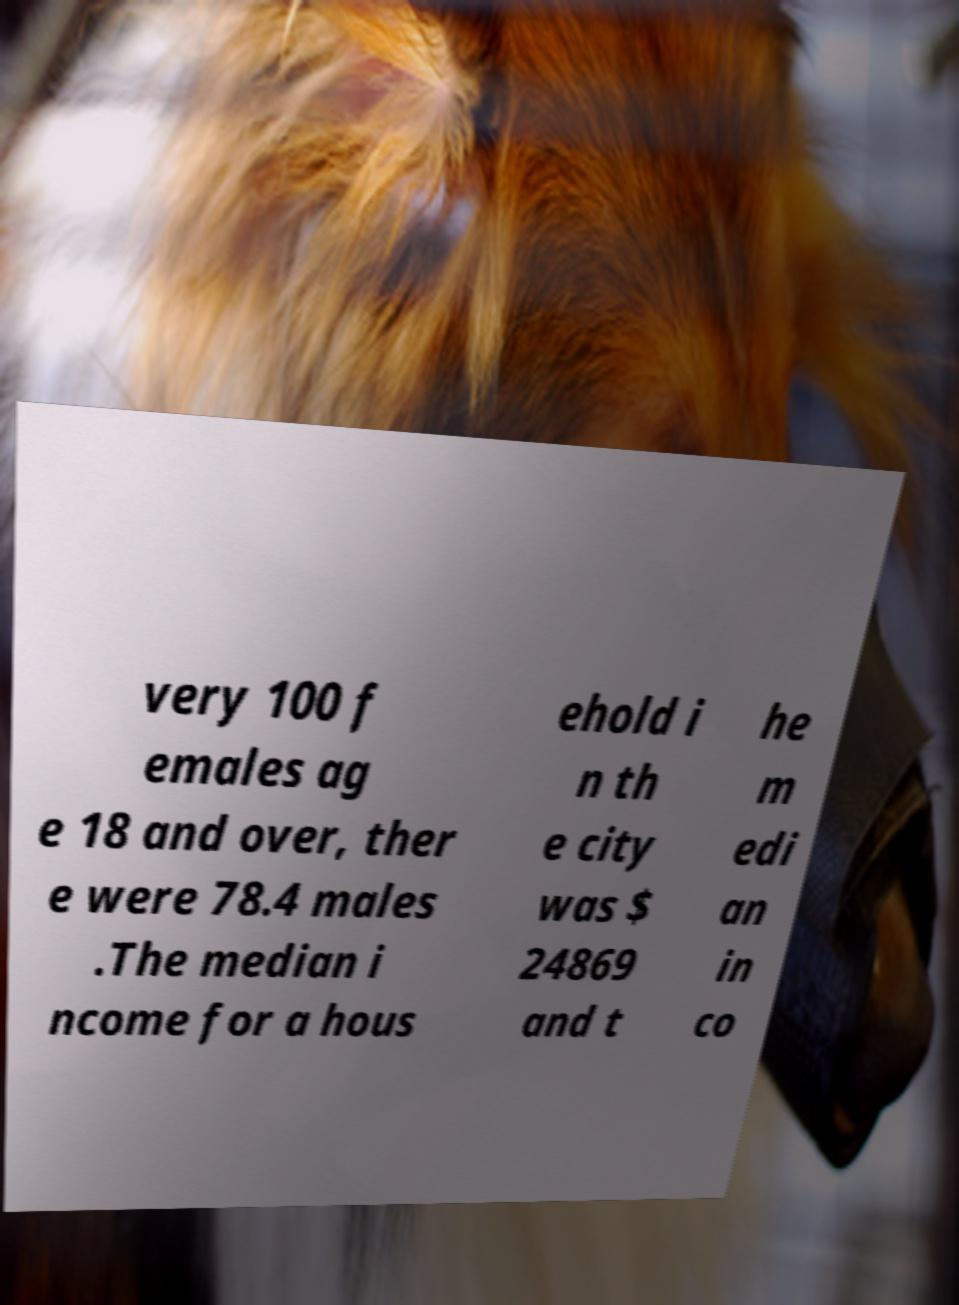Please read and relay the text visible in this image. What does it say? very 100 f emales ag e 18 and over, ther e were 78.4 males .The median i ncome for a hous ehold i n th e city was $ 24869 and t he m edi an in co 